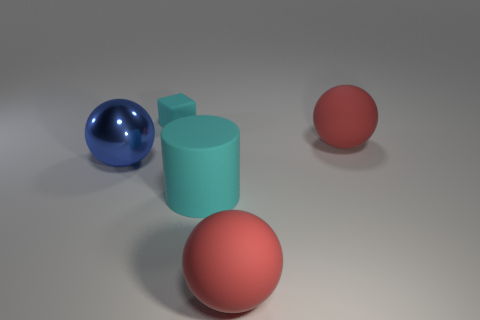Add 4 cyan metal balls. How many objects exist? 9 Subtract all spheres. How many objects are left? 2 Subtract 0 brown spheres. How many objects are left? 5 Subtract all large yellow shiny balls. Subtract all tiny objects. How many objects are left? 4 Add 3 blue spheres. How many blue spheres are left? 4 Add 4 large red rubber spheres. How many large red rubber spheres exist? 6 